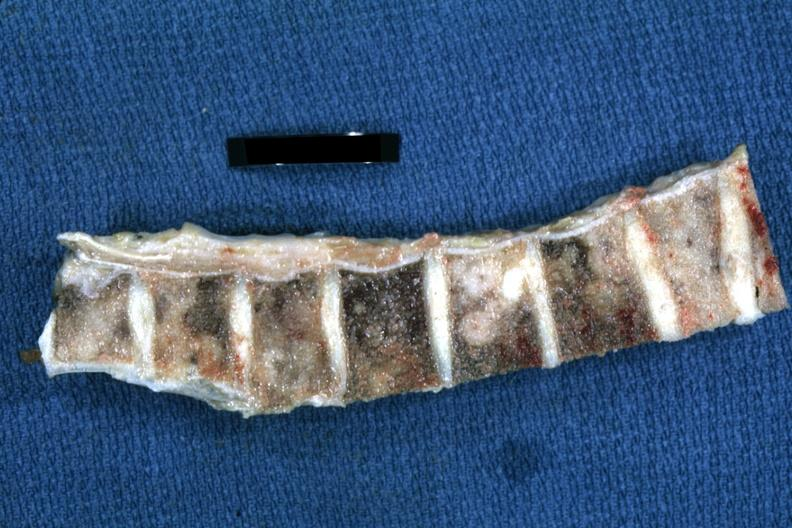s joints present?
Answer the question using a single word or phrase. Yes 